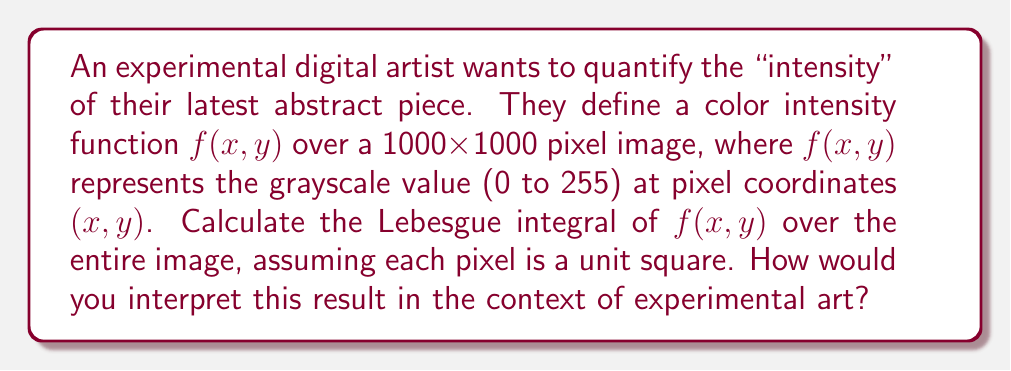Help me with this question. To solve this problem, we'll follow these steps:

1) First, we need to understand what the Lebesgue integral represents in this context. The Lebesgue integral of $f(x,y)$ over the image will give us the total "intensity" of the image, considering all pixels.

2) The image is 1000x1000 pixels, so our domain is $[0,1000] \times [0,1000]$.

3) For a discrete image, we can represent the Lebesgue integral as a sum over all pixels:

   $$\int_{[0,1000] \times [0,1000]} f(x,y) d\mu = \sum_{x=0}^{999} \sum_{y=0}^{999} f(x,y)$$

4) We're told that $f(x,y)$ represents the grayscale value at each pixel, ranging from 0 to 255.

5) Without knowing the specific values of $f(x,y)$ for each pixel, we can't calculate an exact value. However, we can determine the range of possible values:

   Minimum possible value: If all pixels are black (0), the integral would be 0.
   Maximum possible value: If all pixels are white (255), the integral would be $255 \times 1000 \times 1000 = 255,000,000$.

6) Therefore, the Lebesgue integral will be a value between 0 and 255,000,000.

Interpretation in the context of experimental art:
The result of this integral represents the total "intensity" or "brightness" of the image. A higher value indicates a brighter overall image, while a lower value indicates a darker image. This quantitative measure could be used to compare different pieces, analyze the artist's use of light and dark, or even as a parameter in generative art algorithms. It provides a mathematical perspective on the visual impact of the piece, bridging the gap between abstract art and quantitative analysis.
Answer: The Lebesgue integral of $f(x,y)$ over the 1000x1000 pixel image will be a value between 0 and 255,000,000, representing the total intensity of the image. The exact value depends on the specific grayscale values of each pixel in the artwork. 